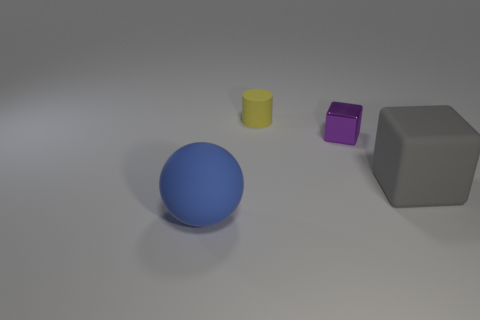Subtract all purple blocks. How many blocks are left? 1 Subtract all balls. How many objects are left? 3 Subtract all red cubes. Subtract all cyan balls. How many cubes are left? 2 Subtract all brown balls. How many cyan cylinders are left? 0 Subtract all yellow metal cylinders. Subtract all big objects. How many objects are left? 2 Add 1 blocks. How many blocks are left? 3 Add 4 small metallic objects. How many small metallic objects exist? 5 Add 2 large gray objects. How many objects exist? 6 Subtract 0 yellow balls. How many objects are left? 4 